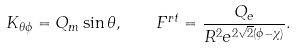Convert formula to latex. <formula><loc_0><loc_0><loc_500><loc_500>K _ { \theta \phi } = Q _ { m } \sin \theta , \quad F ^ { r t } = \frac { Q _ { e } } { R ^ { 2 } e ^ { 2 \sqrt { 2 } ( \phi - \chi ) } } .</formula> 